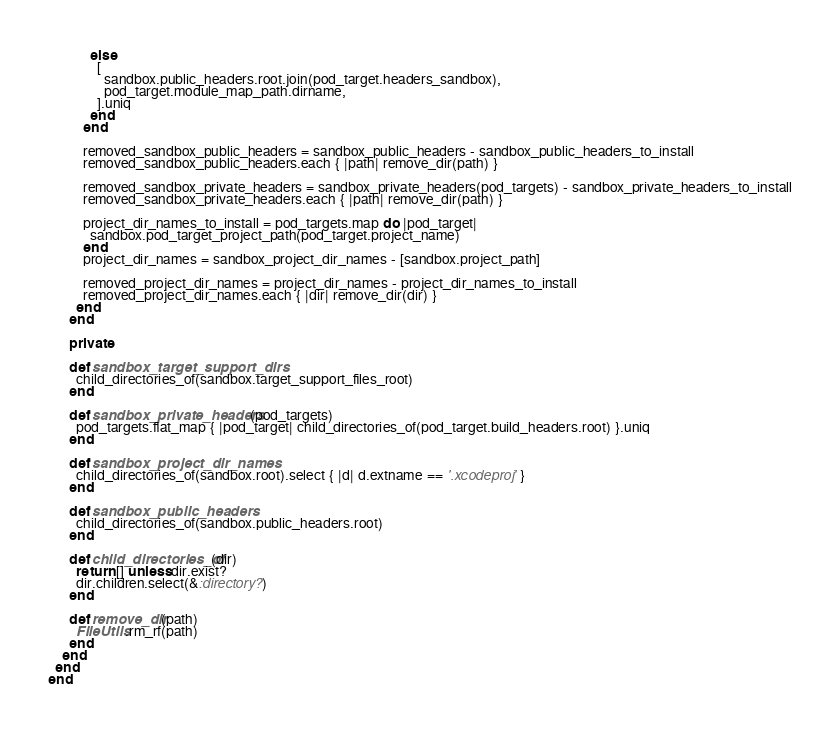Convert code to text. <code><loc_0><loc_0><loc_500><loc_500><_Ruby_>            else
              [
                sandbox.public_headers.root.join(pod_target.headers_sandbox),
                pod_target.module_map_path.dirname,
              ].uniq
            end
          end

          removed_sandbox_public_headers = sandbox_public_headers - sandbox_public_headers_to_install
          removed_sandbox_public_headers.each { |path| remove_dir(path) }

          removed_sandbox_private_headers = sandbox_private_headers(pod_targets) - sandbox_private_headers_to_install
          removed_sandbox_private_headers.each { |path| remove_dir(path) }

          project_dir_names_to_install = pod_targets.map do |pod_target|
            sandbox.pod_target_project_path(pod_target.project_name)
          end
          project_dir_names = sandbox_project_dir_names - [sandbox.project_path]

          removed_project_dir_names = project_dir_names - project_dir_names_to_install
          removed_project_dir_names.each { |dir| remove_dir(dir) }
        end
      end

      private

      def sandbox_target_support_dirs
        child_directories_of(sandbox.target_support_files_root)
      end

      def sandbox_private_headers(pod_targets)
        pod_targets.flat_map { |pod_target| child_directories_of(pod_target.build_headers.root) }.uniq
      end

      def sandbox_project_dir_names
        child_directories_of(sandbox.root).select { |d| d.extname == '.xcodeproj' }
      end

      def sandbox_public_headers
        child_directories_of(sandbox.public_headers.root)
      end

      def child_directories_of(dir)
        return [] unless dir.exist?
        dir.children.select(&:directory?)
      end

      def remove_dir(path)
        FileUtils.rm_rf(path)
      end
    end
  end
end
</code> 